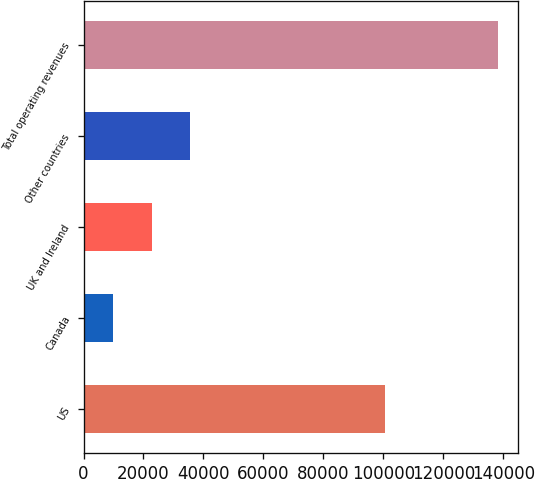<chart> <loc_0><loc_0><loc_500><loc_500><bar_chart><fcel>US<fcel>Canada<fcel>UK and Ireland<fcel>Other countries<fcel>Total operating revenues<nl><fcel>100418<fcel>9974<fcel>22784<fcel>35594<fcel>138074<nl></chart> 